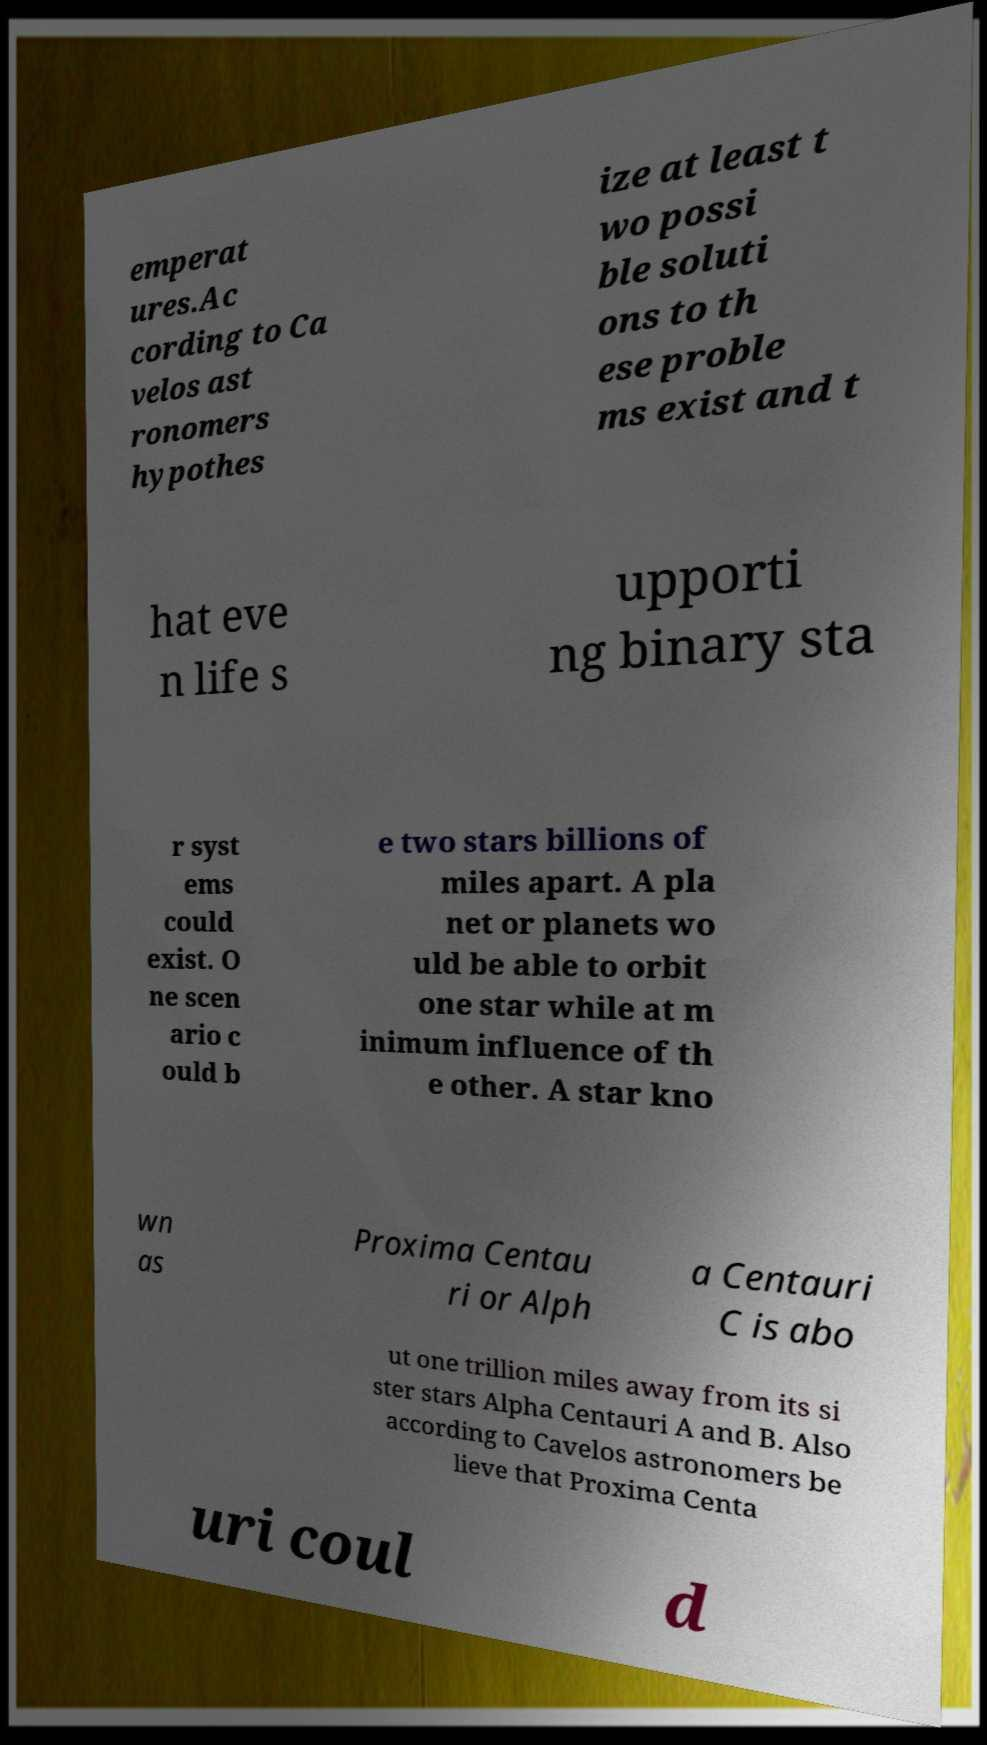Could you assist in decoding the text presented in this image and type it out clearly? emperat ures.Ac cording to Ca velos ast ronomers hypothes ize at least t wo possi ble soluti ons to th ese proble ms exist and t hat eve n life s upporti ng binary sta r syst ems could exist. O ne scen ario c ould b e two stars billions of miles apart. A pla net or planets wo uld be able to orbit one star while at m inimum influence of th e other. A star kno wn as Proxima Centau ri or Alph a Centauri C is abo ut one trillion miles away from its si ster stars Alpha Centauri A and B. Also according to Cavelos astronomers be lieve that Proxima Centa uri coul d 